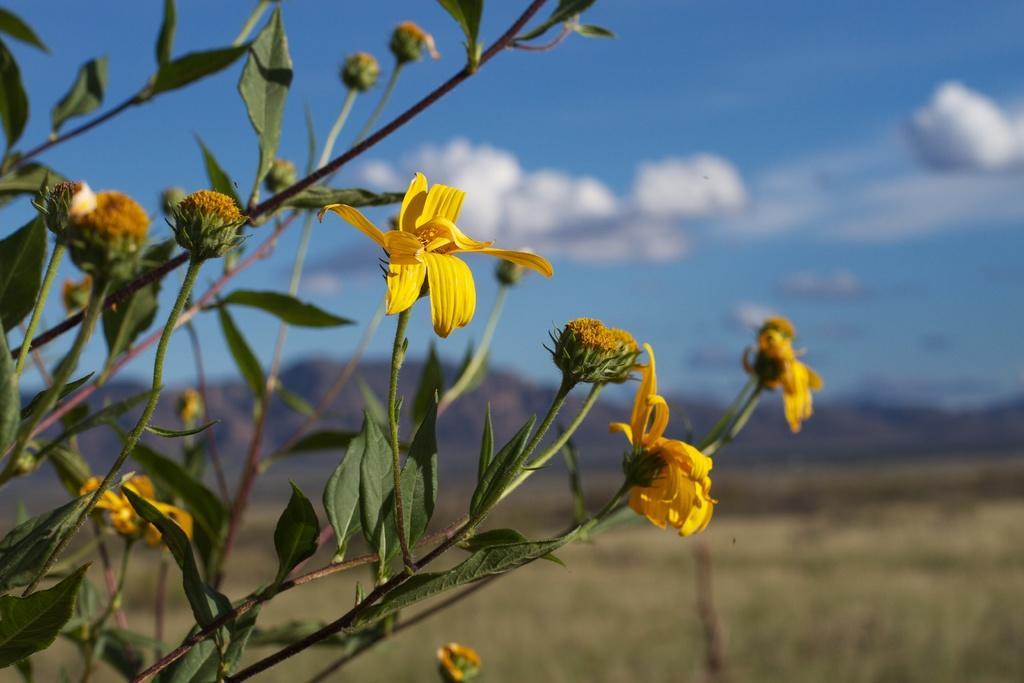Describe this image in one or two sentences. To this plant there are flowers and buds. Background it is blurry and we can see clouds.  